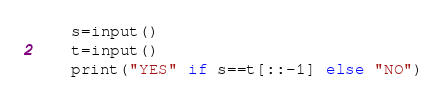<code> <loc_0><loc_0><loc_500><loc_500><_Python_>    s=input()
    t=input()
    print("YES" if s==t[::-1] else "NO")</code> 